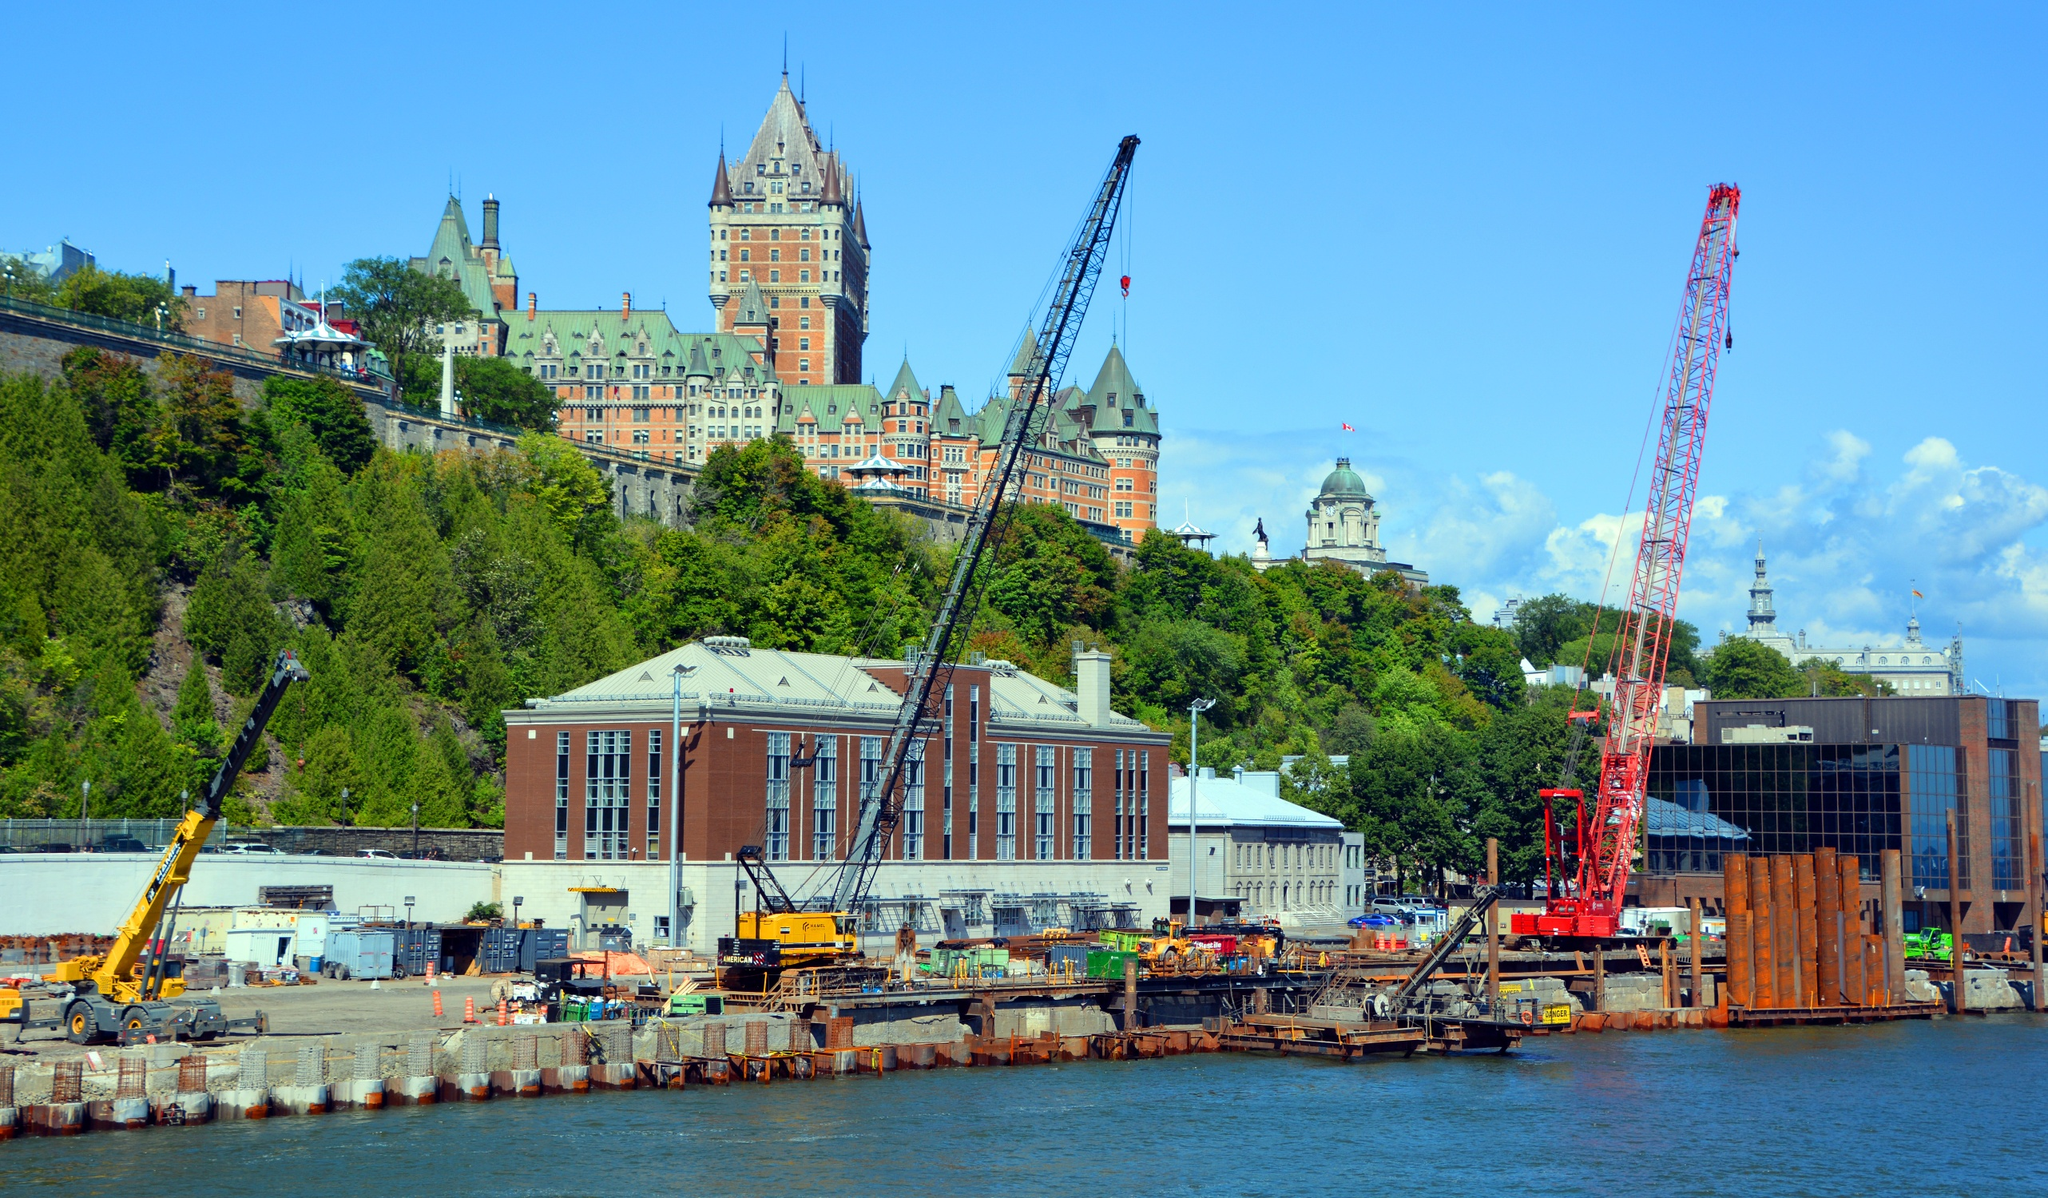What are the visible natural features around the Château Frontenac in the image? The natural features surrounding the Château Frontenac in the image include a lush hillside adorned with abundant greenery. Trees dot the landscape, providing a refreshing contrast to the urban and architectural elements. The vegetation adds a touch of nature's serenity against the hotel's historic backdrop. Additionally, the calm waters of the St. Lawrence River occupy the bottom left corner of the image, contributing to the picturesque and tranquil ambiance of the scene. Describe a day in the life of a construction worker on the site in front of Château Frontenac. A typical day for a construction worker on the site in front of the Château Frontenac begins early in the morning. As dawn breaks, the worker gears up in protective attire and joins the team for a quick briefing about the day's tasks. Throughout the day, the worker maneuvers heavy machinery like cranes and excavators, collaborating with colleagues to erect new structures and ensure site safety. Amid the hustle and noise, the worker occasionally glances up at the towering Château Frontenac, a reminder of the city's rich history. The day ends as the sun sets, casting golden hues over the iron giant, leaving the worker with a sense of accomplishment and connection to the transformative process of the urban landscape. What might the Château Frontenac itself 'say' if it could speak about the ongoing construction before it? "I am the Château Frontenac, a sentinel of history who has watched over this city for over a century. Born of the dreams of travelers, I have seen the world change, wars fought, and peace celebrated within my walls. The construction before me is a testament to progress and innovation. Though the sounds of machinery starkly contrast the melodies of the past, they represent the vibrant pulse of a city unceasingly moving forward. I welcome this evolution, knowing that each brick laid below adds to the story of our shared future." 